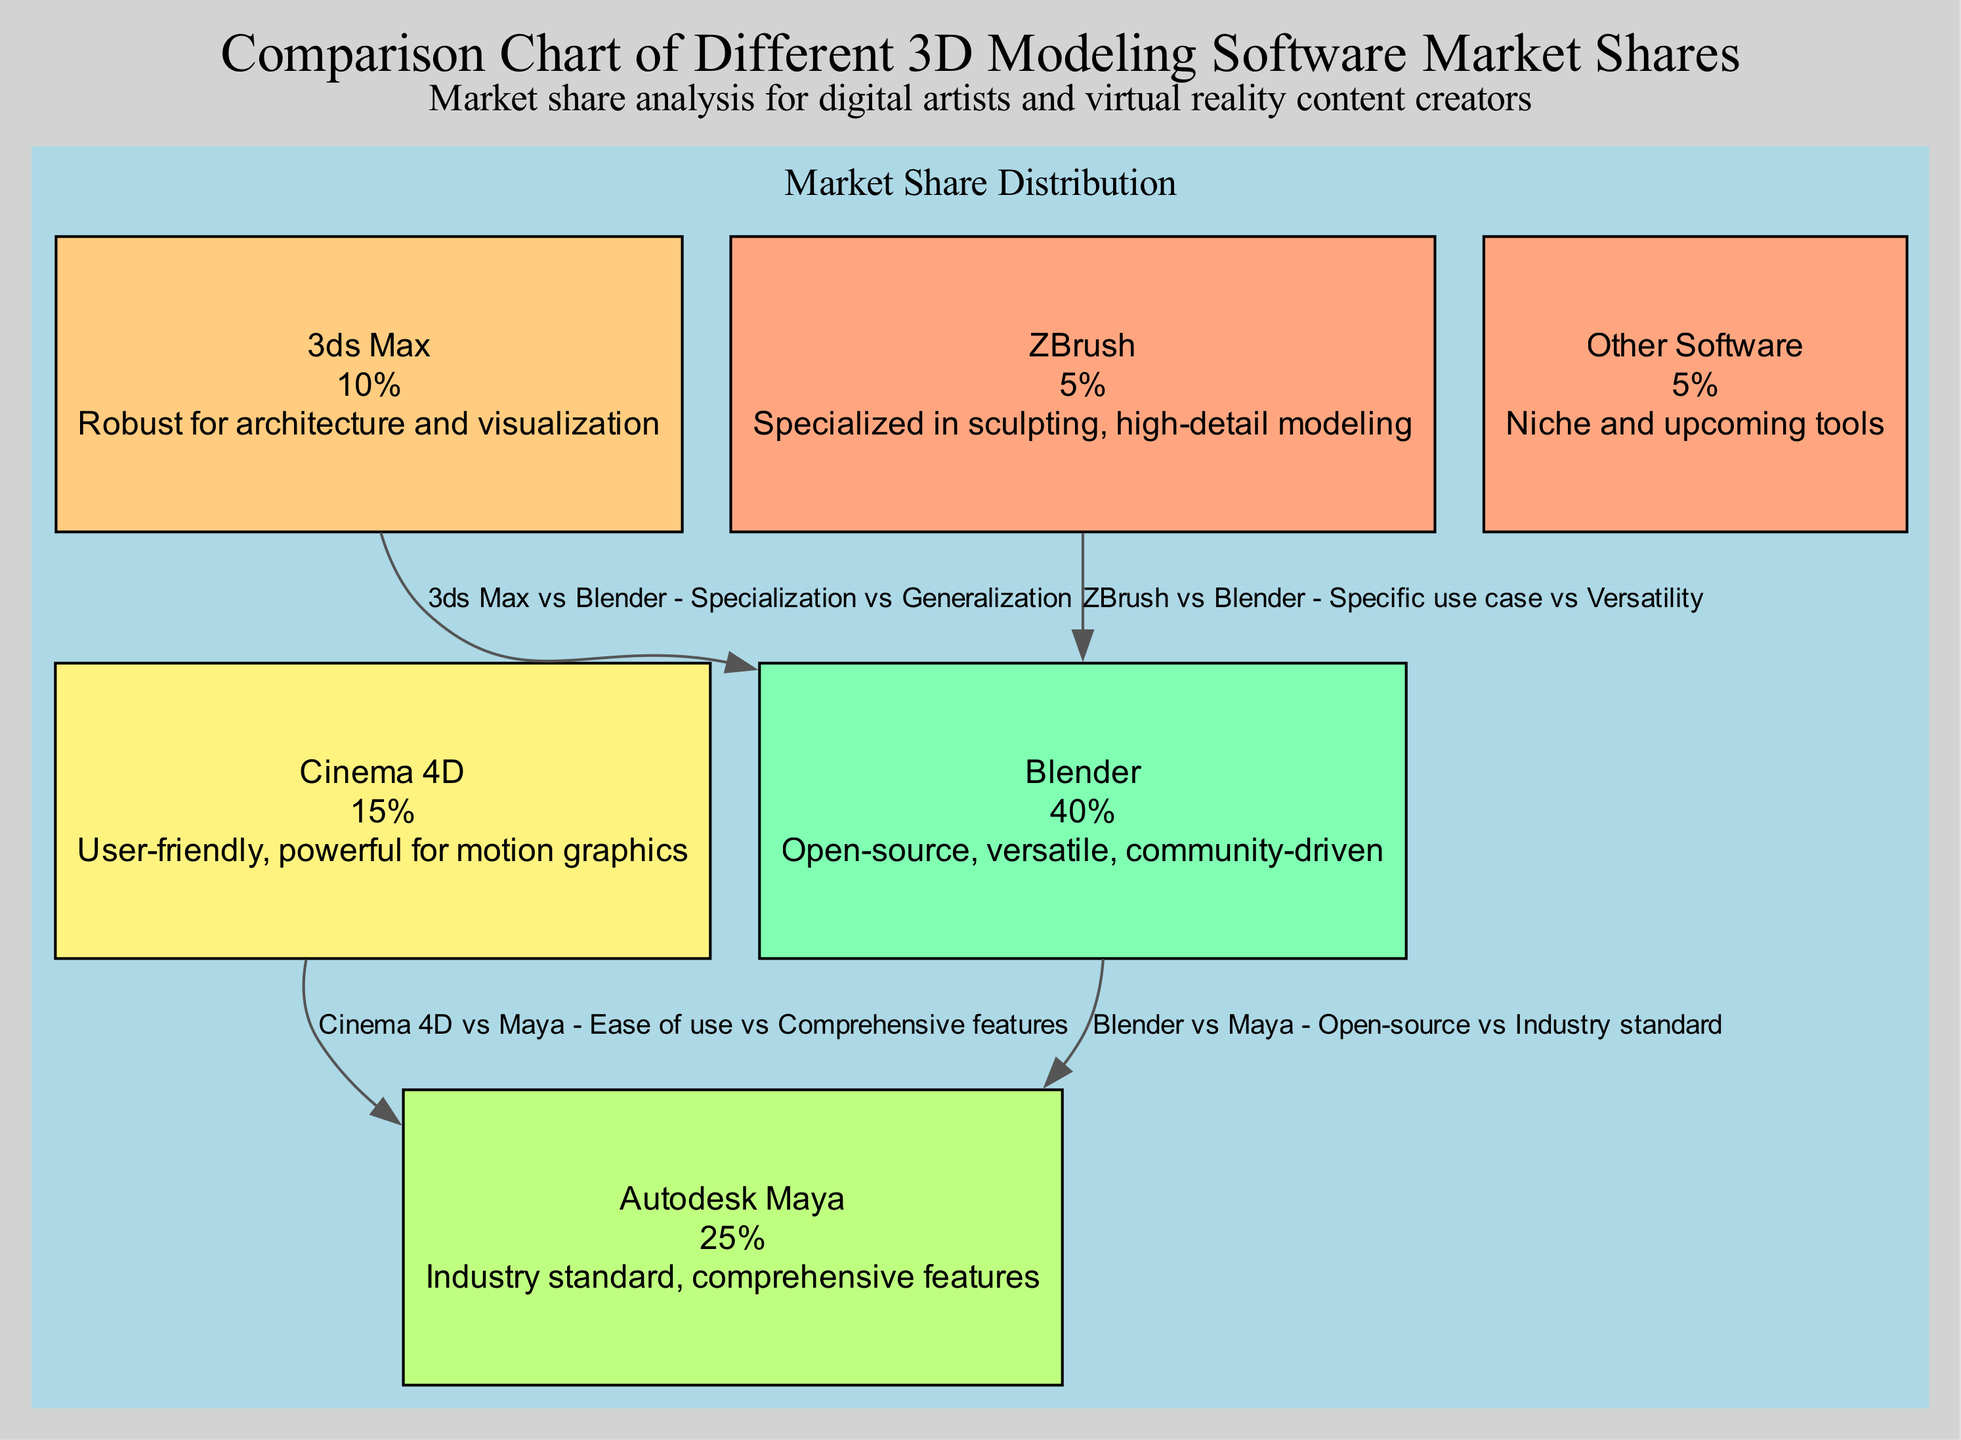What is the market share of Blender? The market share of Blender is explicitly stated in the diagram. It shows "40%" directly below the Blender label.
Answer: 40% What software has the second highest market share? To determine the second highest market share, we can compare the values listed. Blender has 40%, Autodesk Maya comes next with 25%, making it the second highest.
Answer: Autodesk Maya How many nodes are there in the diagram? The diagram lists several software as nodes. By counting the nodes under "Market Share Distribution", we find there are a total of six entries: Blender, Autodesk Maya, Cinema 4D, 3ds Max, ZBrush, and Other Software.
Answer: 6 What does the edge label "Blender vs Maya - Open-source vs Industry standard" imply? The edge label indicates a comparison between Blender and Autodesk Maya. It highlights that Blender is open-source, while Autodesk Maya is an industry standard. This comparison indicates the different appeals of these software options.
Answer: Open-source vs Industry standard Which software is specialized in sculpting? Referring to the descriptions provided, ZBrush is specifically mentioned as being "Specialized in sculpting, high-detail modeling," highlighting its focused purpose compared to others.
Answer: ZBrush Which two software have a total market share of 50%? By combining the market shares of Blender (40%) and Autodesk Maya (25%), this pair totals to 65%. Assessing other combinations, only Blender (40%) and Other Software (5%) or ZBrush (5%) will sum to 45%. No two entries combine for exactly 50%.
Answer: None How does the market share of Cinema 4D compare to 3ds Max? The market shares show that Cinema 4D has a share of 15%, while 3ds Max has a share of 10%. This comparison shows that Cinema 4D exceeds the share of 3ds Max by 5%.
Answer: Higher What description is associated with the software that has a market share of 10%? Looking at the market shares, the software with a 10% share is 3ds Max, which is described as "Robust for architecture and visualization." This description indicates its strength in specific applications such as architectural modeling.
Answer: Robust for architecture and visualization What is the relationship between Blender and ZBrush based on the diagram? The edge labeled "ZBrush vs Blender - Specific use case vs Versatility" highlights a comparative analysis. ZBrush is noted for a specific use case in sculpting, while Blender is characterized by its overall versatility. This illustrates the different strengths of each software in the context of modeling capabilities.
Answer: Specific use case vs Versatility 